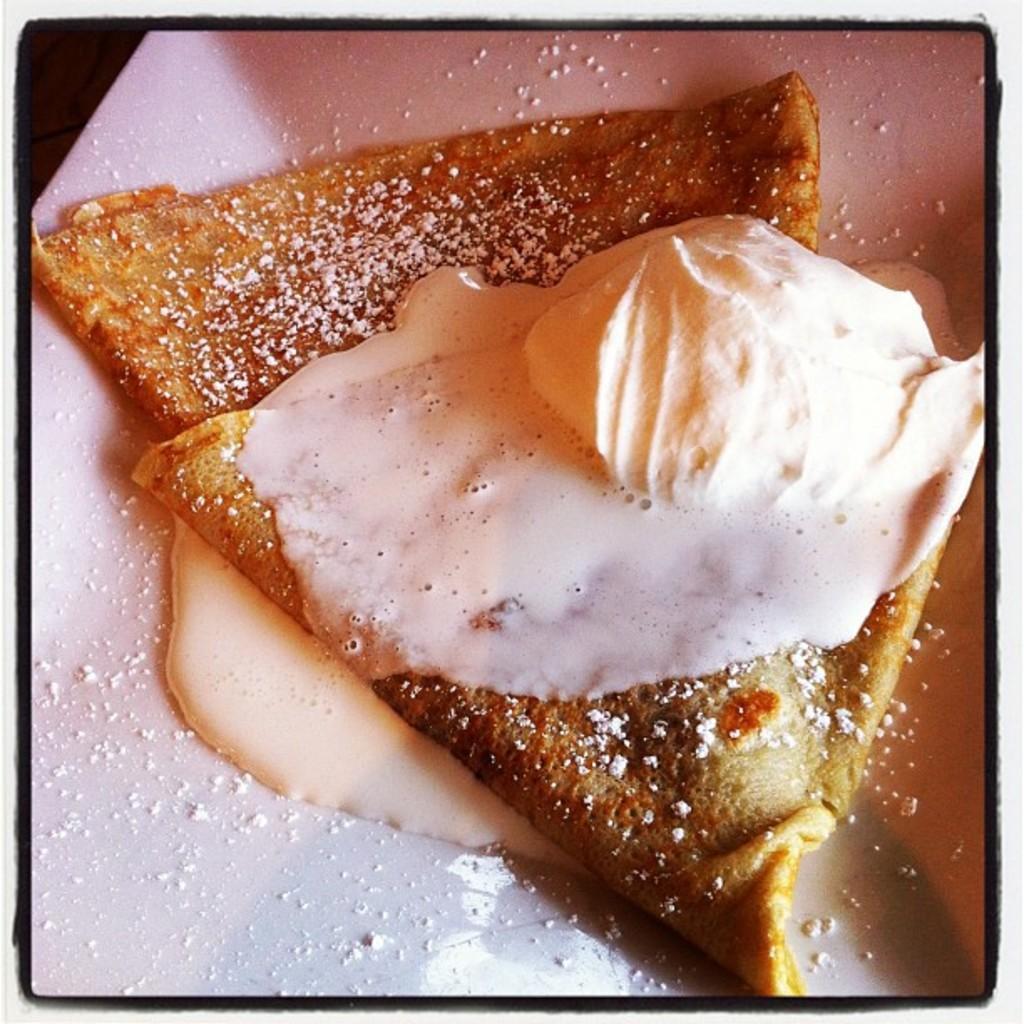Describe this image in one or two sentences. In this image, there is a plate contains some food. 